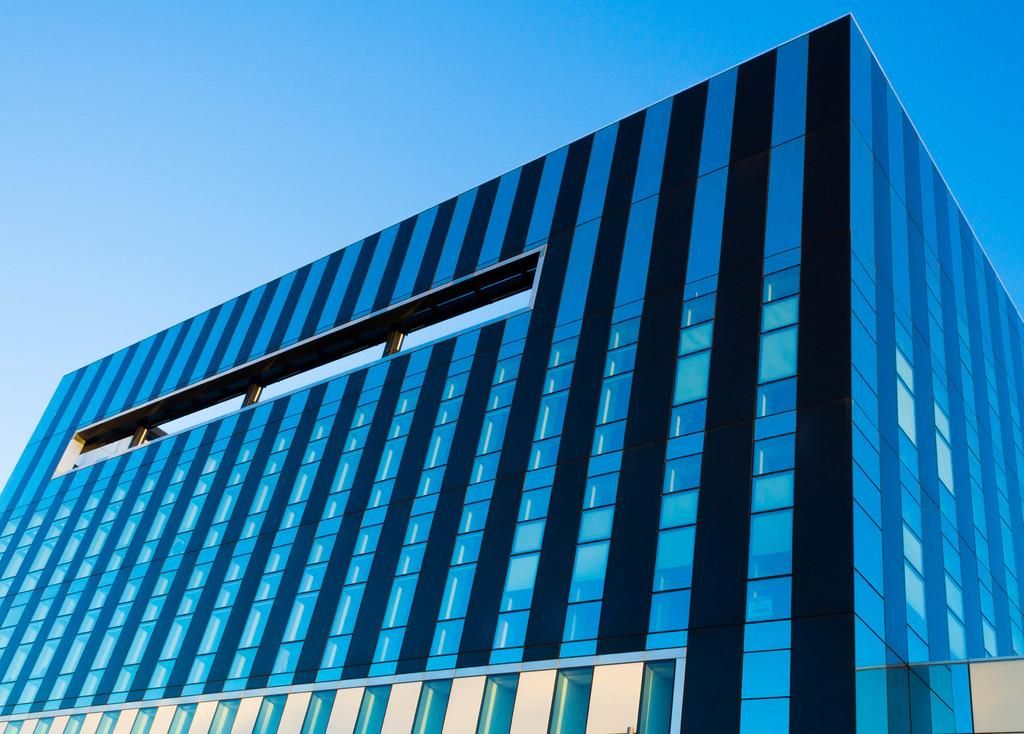What type of building is shown in the image? There is a glass building in the image. What architectural features can be seen in the image? Pillars are visible in the image. What is visible at the top of the image? The sky is visible at the top of the image. How many owls are sitting on the truck in the image? There are no owls or trucks present in the image. What is the value of the cent depicted in the image? There is no cent present in the image. 